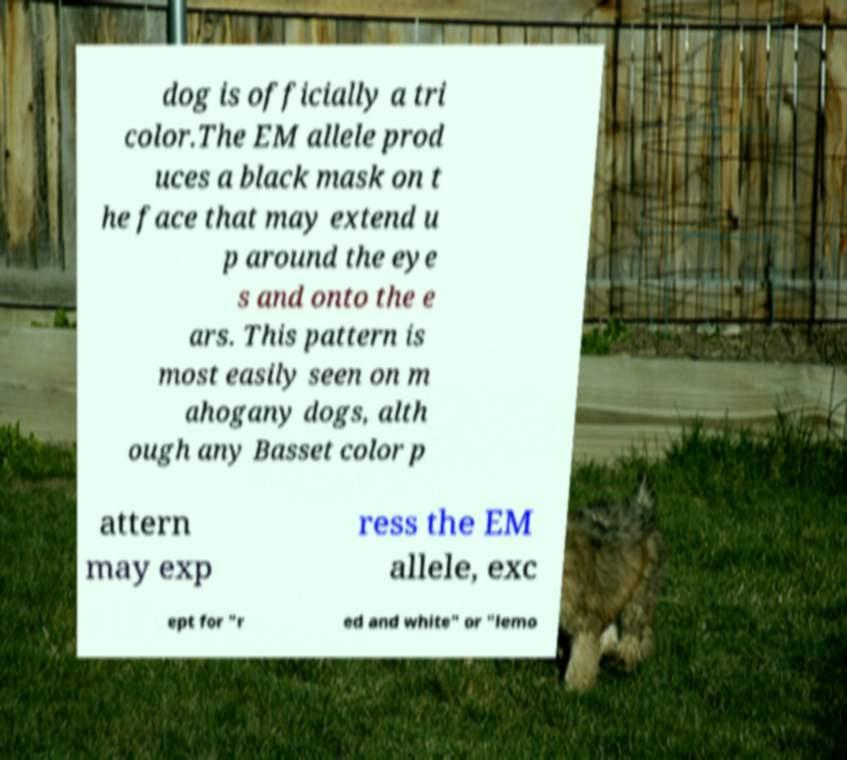Could you assist in decoding the text presented in this image and type it out clearly? dog is officially a tri color.The EM allele prod uces a black mask on t he face that may extend u p around the eye s and onto the e ars. This pattern is most easily seen on m ahogany dogs, alth ough any Basset color p attern may exp ress the EM allele, exc ept for "r ed and white" or "lemo 